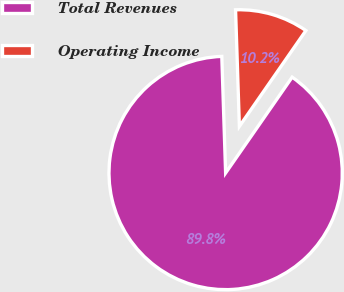<chart> <loc_0><loc_0><loc_500><loc_500><pie_chart><fcel>Total Revenues<fcel>Operating Income<nl><fcel>89.82%<fcel>10.18%<nl></chart> 